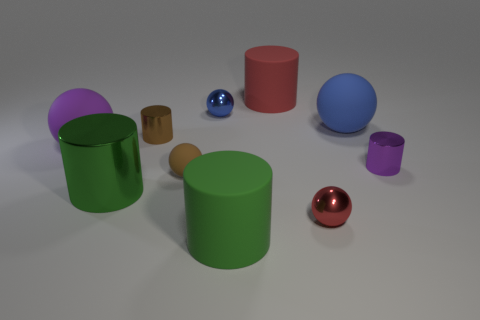How many other objects are the same shape as the blue rubber object? Including the blue rubber object, there are three spherical objects in total. The apparent material or texture nuances among the objects are not factored into this count; it's purely a shape-based observation. 